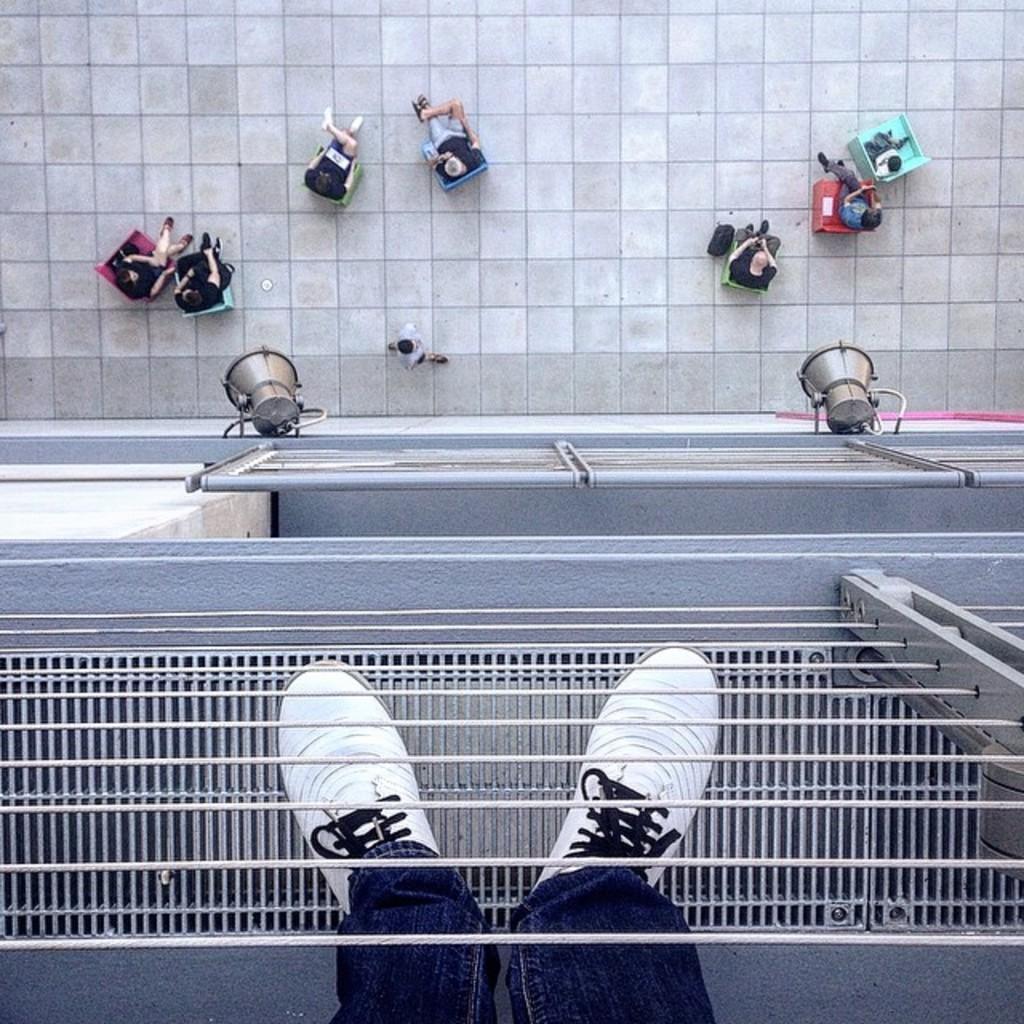Please provide a concise description of this image. At the bottom of the image we can see human legs, shoes, fences and a few other objects. In the background, we can see one person is standing and a few people are sitting on the chairs. And we can see one building, fences and a few other objects. 